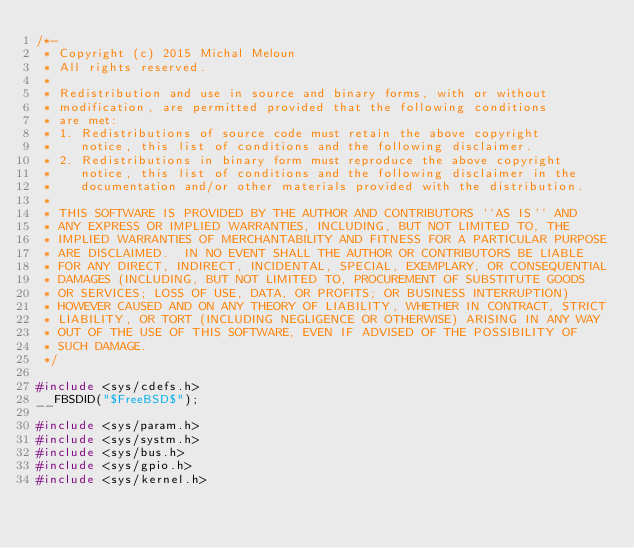<code> <loc_0><loc_0><loc_500><loc_500><_C_>/*-
 * Copyright (c) 2015 Michal Meloun
 * All rights reserved.
 *
 * Redistribution and use in source and binary forms, with or without
 * modification, are permitted provided that the following conditions
 * are met:
 * 1. Redistributions of source code must retain the above copyright
 *    notice, this list of conditions and the following disclaimer.
 * 2. Redistributions in binary form must reproduce the above copyright
 *    notice, this list of conditions and the following disclaimer in the
 *    documentation and/or other materials provided with the distribution.
 *
 * THIS SOFTWARE IS PROVIDED BY THE AUTHOR AND CONTRIBUTORS ``AS IS'' AND
 * ANY EXPRESS OR IMPLIED WARRANTIES, INCLUDING, BUT NOT LIMITED TO, THE
 * IMPLIED WARRANTIES OF MERCHANTABILITY AND FITNESS FOR A PARTICULAR PURPOSE
 * ARE DISCLAIMED.  IN NO EVENT SHALL THE AUTHOR OR CONTRIBUTORS BE LIABLE
 * FOR ANY DIRECT, INDIRECT, INCIDENTAL, SPECIAL, EXEMPLARY, OR CONSEQUENTIAL
 * DAMAGES (INCLUDING, BUT NOT LIMITED TO, PROCUREMENT OF SUBSTITUTE GOODS
 * OR SERVICES; LOSS OF USE, DATA, OR PROFITS; OR BUSINESS INTERRUPTION)
 * HOWEVER CAUSED AND ON ANY THEORY OF LIABILITY, WHETHER IN CONTRACT, STRICT
 * LIABILITY, OR TORT (INCLUDING NEGLIGENCE OR OTHERWISE) ARISING IN ANY WAY
 * OUT OF THE USE OF THIS SOFTWARE, EVEN IF ADVISED OF THE POSSIBILITY OF
 * SUCH DAMAGE.
 */

#include <sys/cdefs.h>
__FBSDID("$FreeBSD$");

#include <sys/param.h>
#include <sys/systm.h>
#include <sys/bus.h>
#include <sys/gpio.h>
#include <sys/kernel.h></code> 